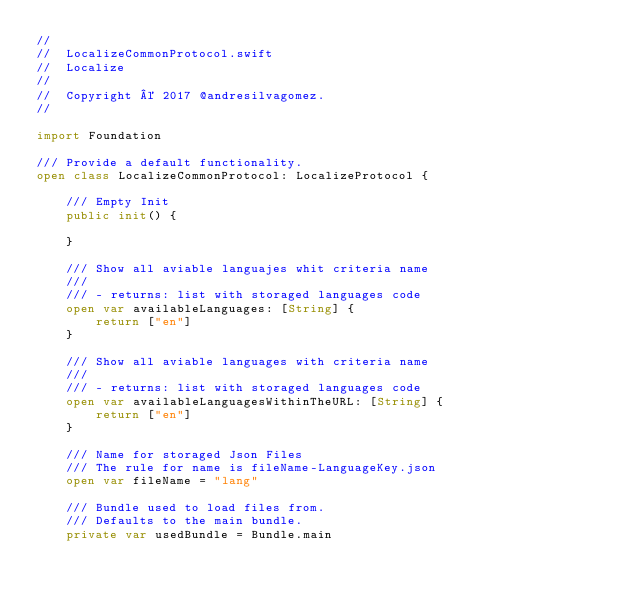Convert code to text. <code><loc_0><loc_0><loc_500><loc_500><_Swift_>//
//  LocalizeCommonProtocol.swift
//  Localize
//
//  Copyright © 2017 @andresilvagomez.
//

import Foundation

/// Provide a default functionality.
open class LocalizeCommonProtocol: LocalizeProtocol {

    /// Empty Init
    public init() {

    }

    /// Show all aviable languajes whit criteria name
    ///
    /// - returns: list with storaged languages code
    open var availableLanguages: [String] {
        return ["en"]
    }
    
    /// Show all aviable languages with criteria name
    ///
    /// - returns: list with storaged languages code
    open var availableLanguagesWithinTheURL: [String] {
        return ["en"]
    }

    /// Name for storaged Json Files
    /// The rule for name is fileName-LanguageKey.json
    open var fileName = "lang"

    /// Bundle used to load files from.
    /// Defaults to the main bundle.
    private var usedBundle = Bundle.main
    </code> 